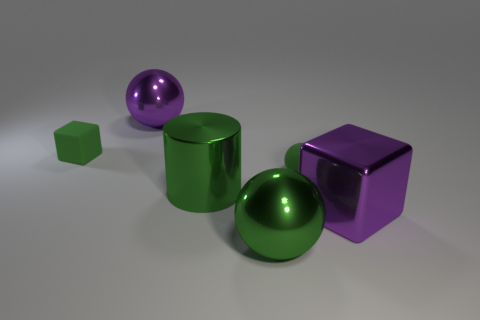There is a big ball that is left of the green metallic ball; is its color the same as the big cube?
Provide a succinct answer. Yes. Does the metal cylinder have the same color as the small matte block?
Ensure brevity in your answer.  Yes. Are there an equal number of big purple balls that are on the right side of the big green sphere and tiny things that are in front of the tiny green rubber cube?
Give a very brief answer. No. What material is the tiny sphere that is the same color as the tiny block?
Make the answer very short. Rubber. Is the material of the small block the same as the small green object that is right of the big green shiny sphere?
Provide a succinct answer. Yes. There is a big thing behind the rubber object that is on the left side of the green metal cylinder that is to the right of the purple ball; what color is it?
Keep it short and to the point. Purple. There is a metallic cylinder; does it have the same color as the shiny ball behind the large block?
Give a very brief answer. No. What is the color of the metallic cylinder?
Give a very brief answer. Green. There is a big shiny object that is behind the small green thing to the right of the green object in front of the big cylinder; what shape is it?
Give a very brief answer. Sphere. What number of other things are there of the same color as the tiny rubber block?
Provide a short and direct response. 3. 